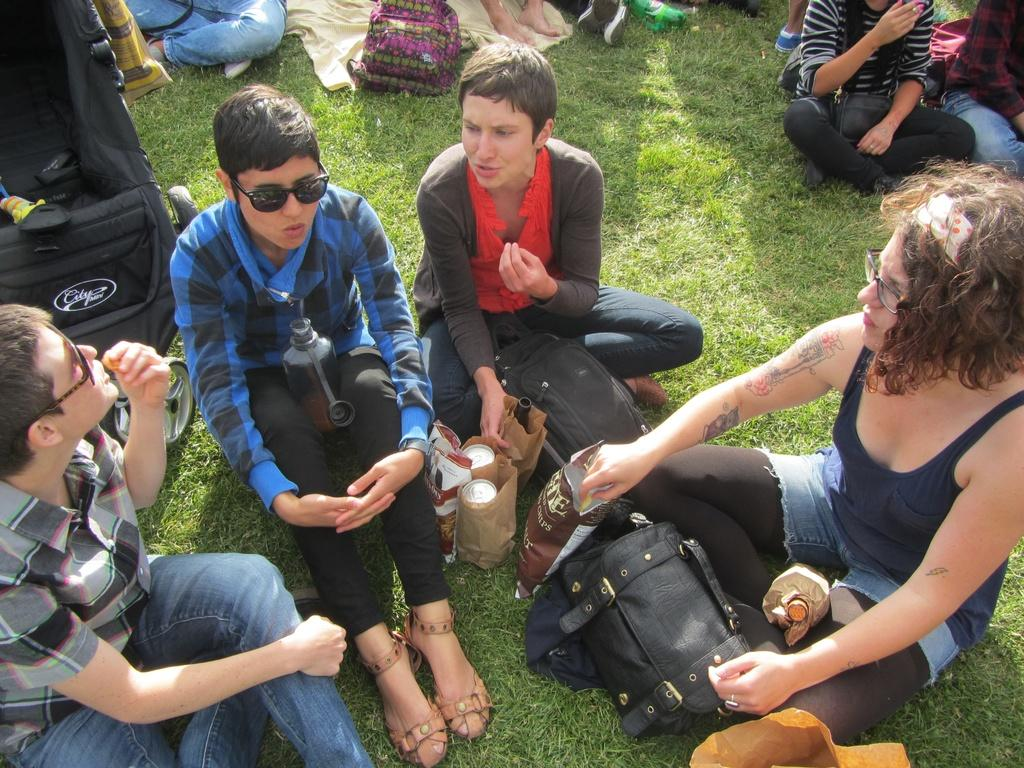What are the people in the image doing? The people in the image are sitting on the grass. What type of containers can be seen in the image? There are tins and packs visible in the image. What type of bags are present in the image? There are bags in the image. What type of surface is visible in the image? There is grass visible in the image. How does the person in the image apply the brake? There is no person applying a brake in the image, as it features people sitting on the grass and various containers and bags. 